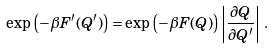<formula> <loc_0><loc_0><loc_500><loc_500>\exp \left ( - \beta F ^ { \prime } ( Q ^ { \prime } ) \right ) = \exp \left ( - \beta F ( Q ) \right ) \left | \frac { \partial Q } { \partial Q ^ { \prime } } \right | \, .</formula> 